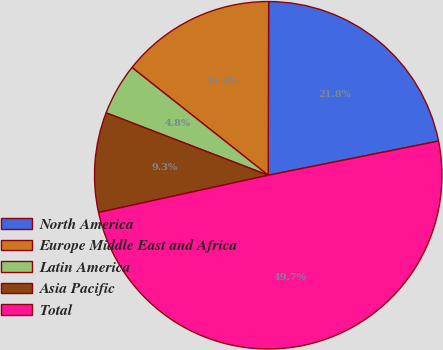Convert chart. <chart><loc_0><loc_0><loc_500><loc_500><pie_chart><fcel>North America<fcel>Europe Middle East and Africa<fcel>Latin America<fcel>Asia Pacific<fcel>Total<nl><fcel>21.81%<fcel>14.39%<fcel>4.8%<fcel>9.29%<fcel>49.72%<nl></chart> 